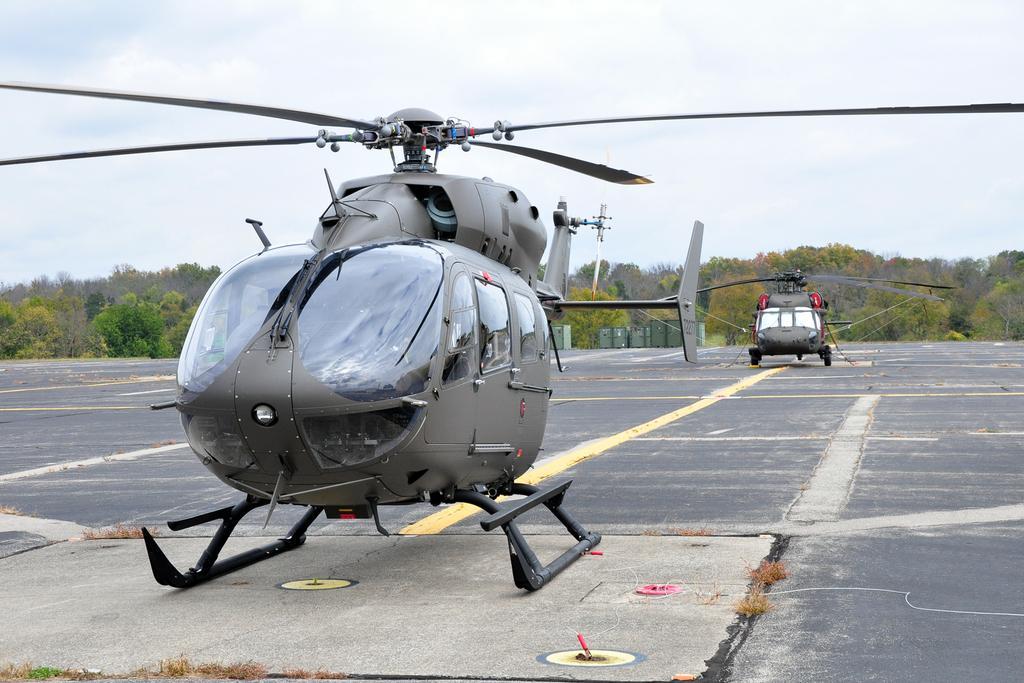In one or two sentences, can you explain what this image depicts? In this image we can see two helicopters on the helipad. We can also see some grass. On the backside we can see some containers, a group of trees and the sky which looks cloudy. 